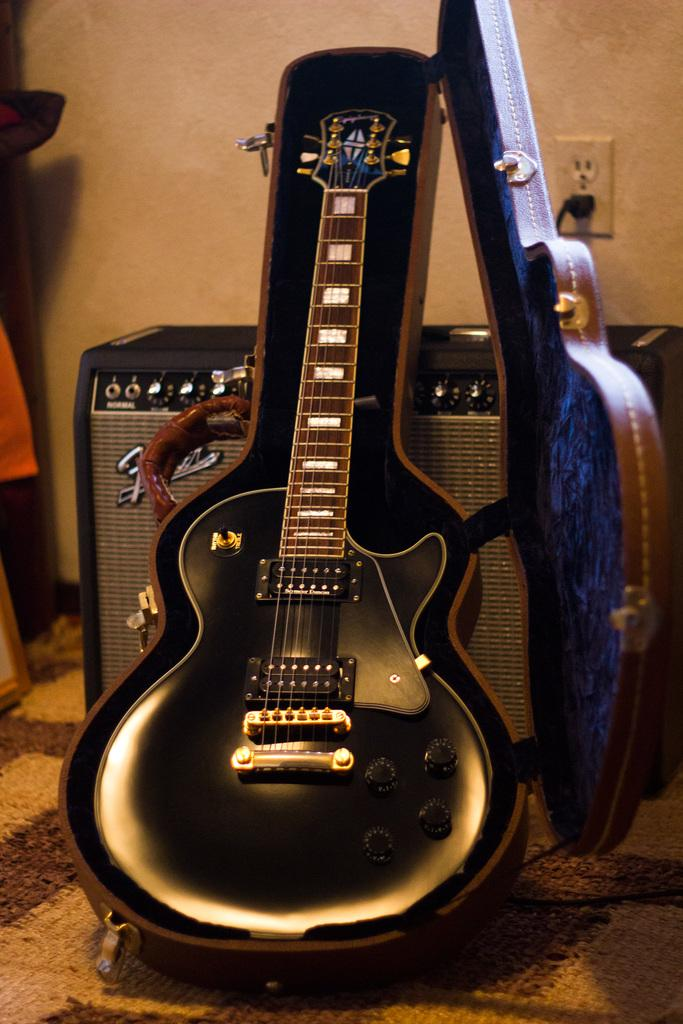What musical instrument is present in the image? There is a guitar in the image. How is the guitar being stored or transported? The guitar is in a guitar box. What audio equipment is visible in the image? There is a speaker on the floor in the image. Can you describe the electrical setup in the background of the image? There is a cable connected to a socket in the background of the image, and the socket is attached to the wall. What type of print can be seen on the sun in the image? There is no sun or print present in the image. 